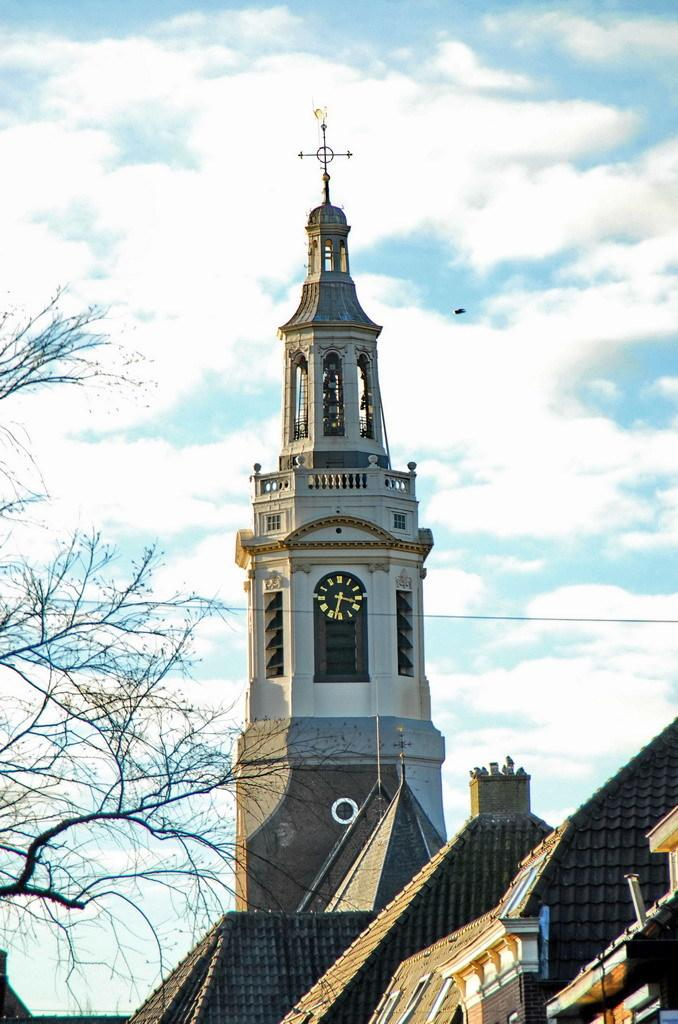What structures are located in the foreground of the image? There are houses and a clock tower in the foreground of the image. What can be seen in the background of the image? The sky and a tree are visible in the background of the image. When was the image taken? The image was taken during the day. What type of straw is used to measure the distance between the houses and the tree in the image? There is no straw present in the image, nor is there any measurement of distance between the houses and the tree. 